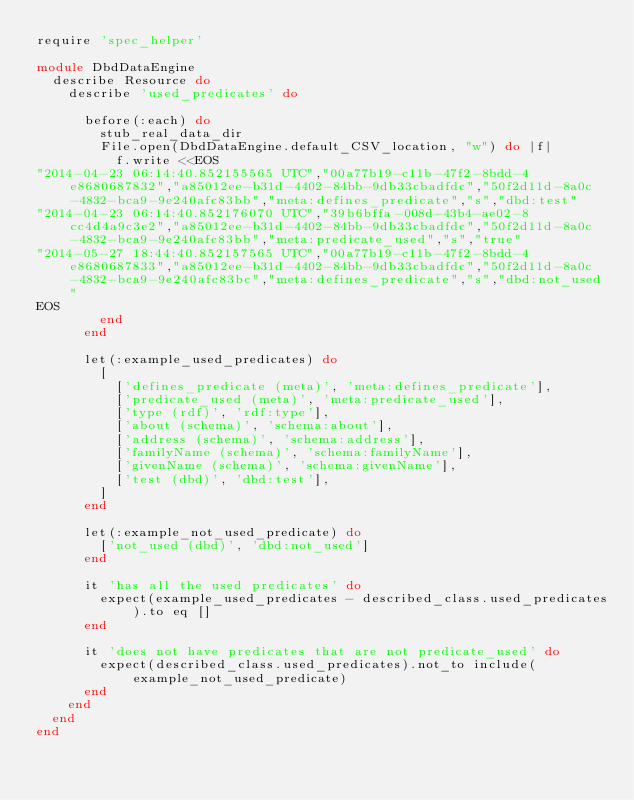<code> <loc_0><loc_0><loc_500><loc_500><_Ruby_>require 'spec_helper'

module DbdDataEngine
  describe Resource do
    describe 'used_predicates' do

      before(:each) do
        stub_real_data_dir
        File.open(DbdDataEngine.default_CSV_location, "w") do |f|
          f.write <<EOS
"2014-04-23 06:14:40.852155565 UTC","00a77b19-c11b-47f2-8bdd-4e8680687832","a85012ee-b31d-4402-84bb-9db33cbadfdc","50f2d11d-8a0c-4832-bca9-9e240afc83bb","meta:defines_predicate","s","dbd:test"
"2014-04-23 06:14:40.852176070 UTC","39b6bffa-008d-43b4-ae02-8cc4d4a9c3e2","a85012ee-b31d-4402-84bb-9db33cbadfdc","50f2d11d-8a0c-4832-bca9-9e240afc83bb","meta:predicate_used","s","true"
"2014-05-27 18:44:40.852157565 UTC","00a77b19-c11b-47f2-8bdd-4e8680687833","a85012ee-b31d-4402-84bb-9db33cbadfdc","50f2d11d-8a0c-4832-bca9-9e240afc83bc","meta:defines_predicate","s","dbd:not_used"
EOS
        end
      end

      let(:example_used_predicates) do
        [
          ['defines_predicate (meta)', 'meta:defines_predicate'],
          ['predicate_used (meta)', 'meta:predicate_used'],
          ['type (rdf)', 'rdf:type'],
          ['about (schema)', 'schema:about'],
          ['address (schema)', 'schema:address'],
          ['familyName (schema)', 'schema:familyName'],
          ['givenName (schema)', 'schema:givenName'],
          ['test (dbd)', 'dbd:test'],
        ]
      end

      let(:example_not_used_predicate) do
        ['not_used (dbd)', 'dbd:not_used']
      end

      it 'has all the used predicates' do
        expect(example_used_predicates - described_class.used_predicates).to eq []
      end

      it 'does not have predicates that are not predicate_used' do
        expect(described_class.used_predicates).not_to include(example_not_used_predicate)
      end
    end
  end
end
</code> 